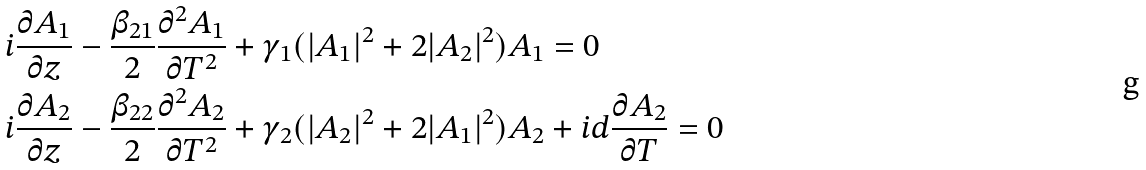<formula> <loc_0><loc_0><loc_500><loc_500>& i \frac { \partial A _ { 1 } } { \partial z } - \frac { \beta _ { 2 1 } } { 2 } \frac { \partial ^ { 2 } A _ { 1 } } { \partial T ^ { 2 } } + \gamma _ { 1 } ( | A _ { 1 } | ^ { 2 } + 2 | A _ { 2 } | ^ { 2 } ) A _ { 1 } = 0 \\ & i \frac { \partial A _ { 2 } } { \partial z } - \frac { \beta _ { 2 2 } } { 2 } \frac { \partial ^ { 2 } A _ { 2 } } { \partial T ^ { 2 } } + \gamma _ { 2 } ( | A _ { 2 } | ^ { 2 } + 2 | A _ { 1 } | ^ { 2 } ) A _ { 2 } + i d \frac { \partial A _ { 2 } } { \partial T } = 0</formula> 